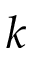Convert formula to latex. <formula><loc_0><loc_0><loc_500><loc_500>k</formula> 